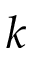Convert formula to latex. <formula><loc_0><loc_0><loc_500><loc_500>k</formula> 